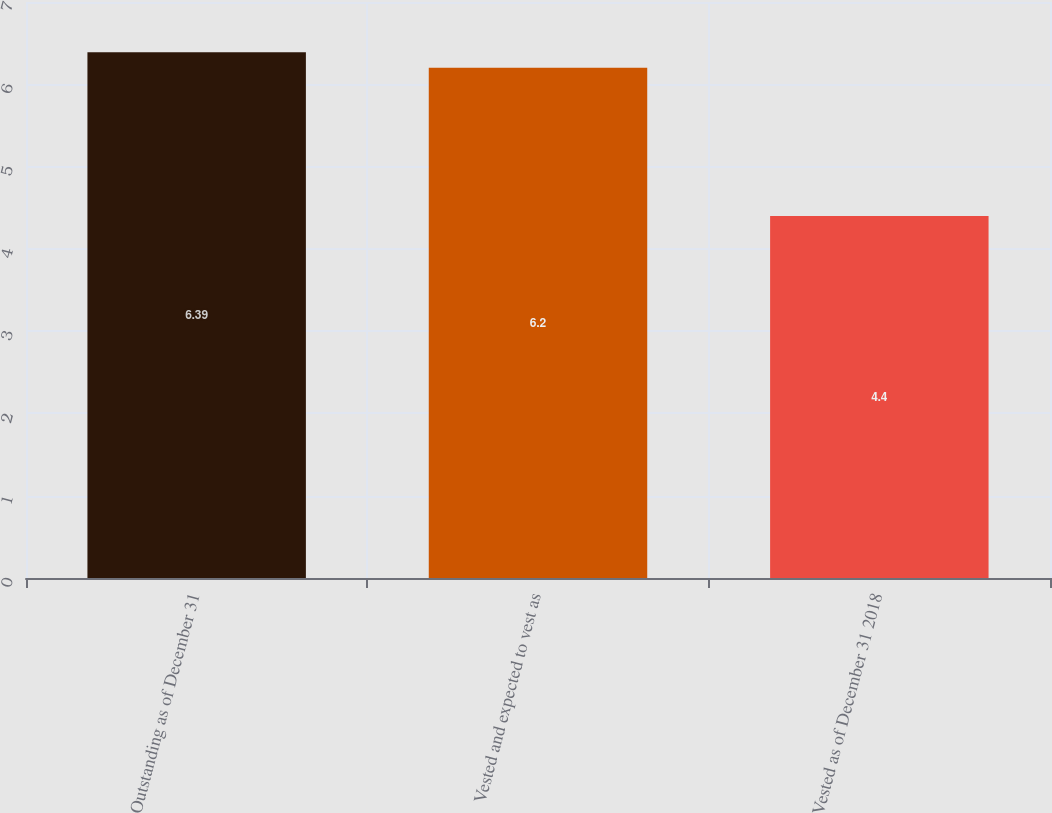Convert chart to OTSL. <chart><loc_0><loc_0><loc_500><loc_500><bar_chart><fcel>Outstanding as of December 31<fcel>Vested and expected to vest as<fcel>Vested as of December 31 2018<nl><fcel>6.39<fcel>6.2<fcel>4.4<nl></chart> 